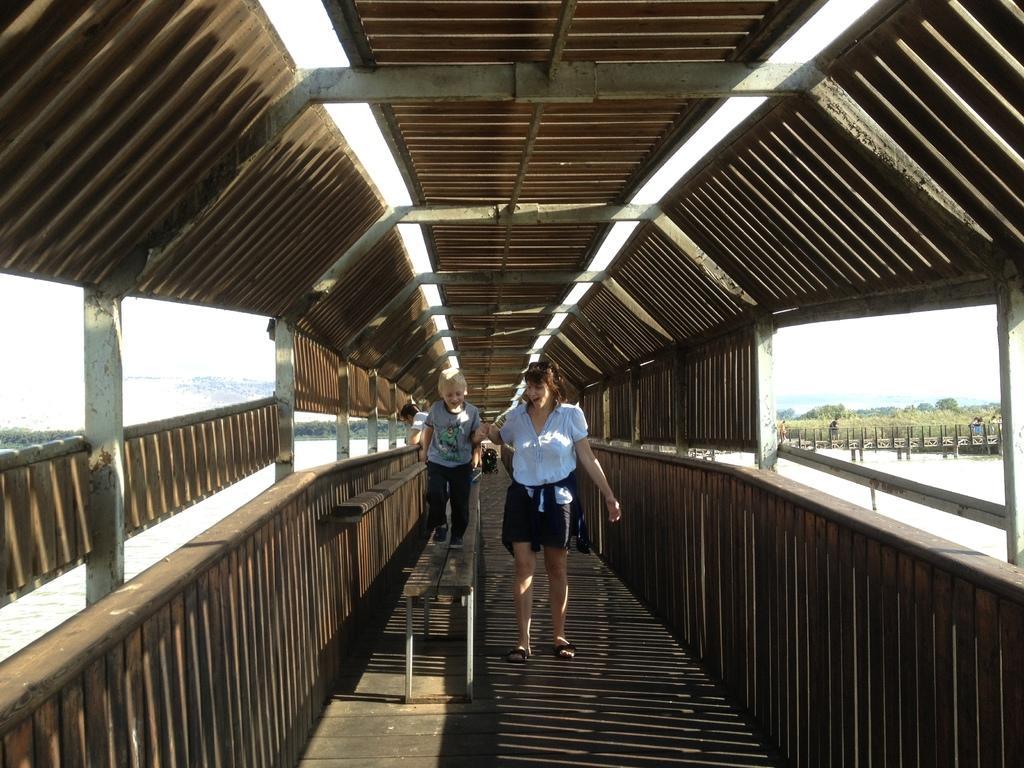Can you describe this image briefly? Woman in the white shirt is holding the hands of a boy and she is smiling. Beside her, boy in a grey t-shirt and black pant is walking on the bench. Both of them are walking on the bridge. Beside that, we see water and we even see the trees and the sky. This picture is clicked outside the city. 